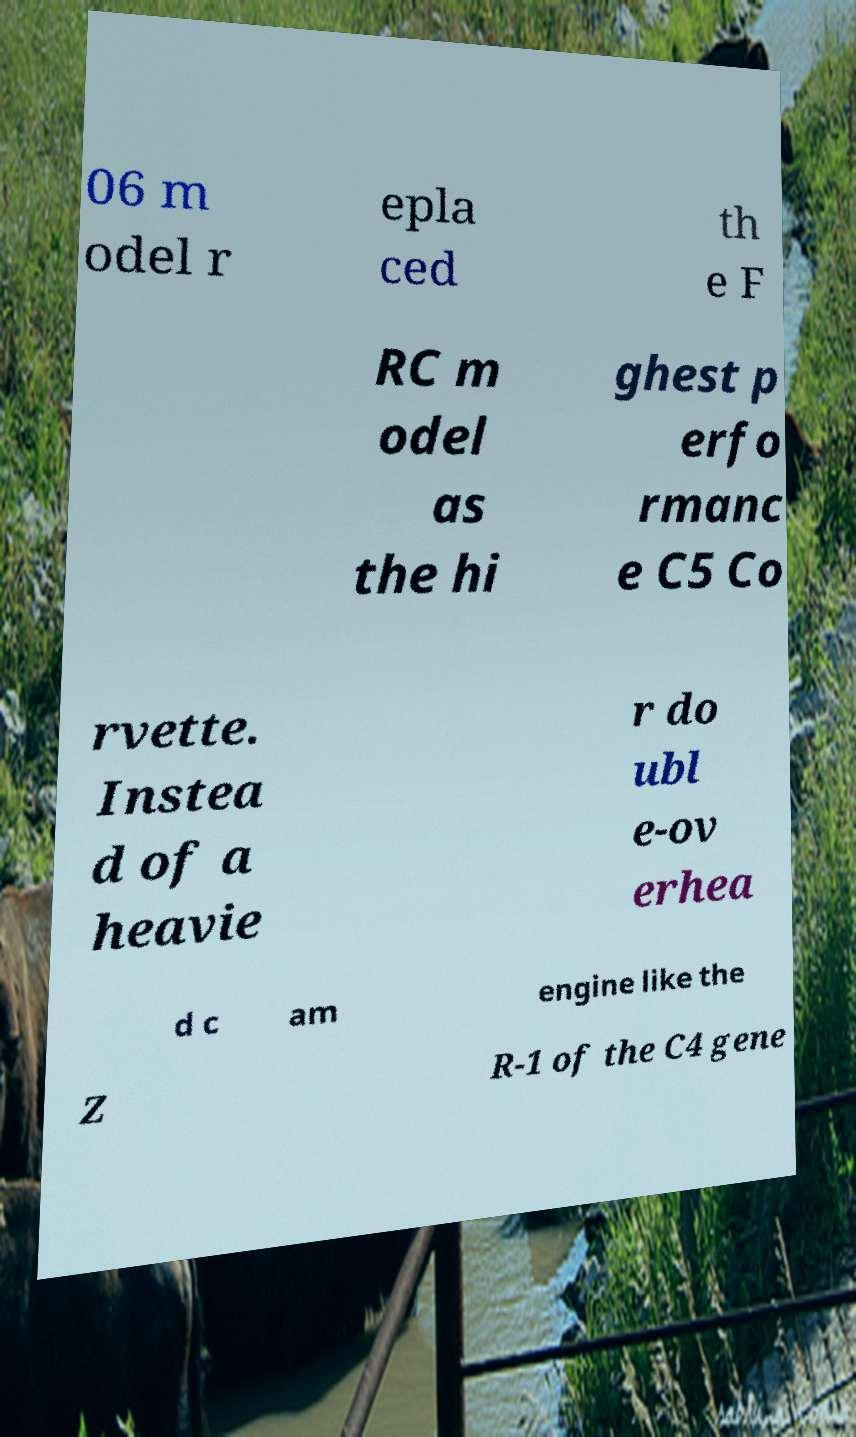Can you accurately transcribe the text from the provided image for me? 06 m odel r epla ced th e F RC m odel as the hi ghest p erfo rmanc e C5 Co rvette. Instea d of a heavie r do ubl e-ov erhea d c am engine like the Z R-1 of the C4 gene 